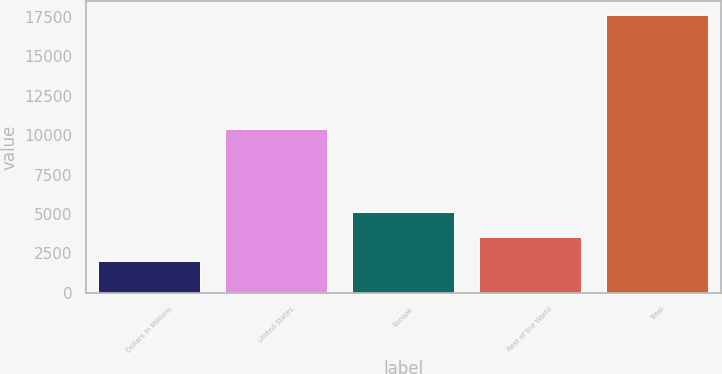Convert chart to OTSL. <chart><loc_0><loc_0><loc_500><loc_500><bar_chart><fcel>Dollars in Millions<fcel>United States<fcel>Europe<fcel>Rest of the World<fcel>Total<nl><fcel>2012<fcel>10384<fcel>5133.8<fcel>3572.9<fcel>17621<nl></chart> 